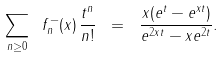Convert formula to latex. <formula><loc_0><loc_0><loc_500><loc_500>\sum _ { n \geq 0 } \ f ^ { - } _ { n } ( x ) \, \frac { t ^ { n } } { n ! } \ = \ \frac { x ( e ^ { t } - e ^ { x t } ) } { e ^ { 2 x t } - x e ^ { 2 t } } .</formula> 